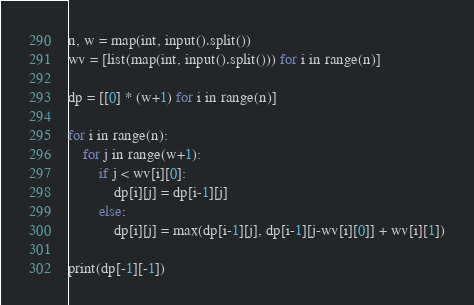Convert code to text. <code><loc_0><loc_0><loc_500><loc_500><_Python_>n, w = map(int, input().split())
wv = [list(map(int, input().split())) for i in range(n)]

dp = [[0] * (w+1) for i in range(n)]

for i in range(n):
    for j in range(w+1):
        if j < wv[i][0]:
            dp[i][j] = dp[i-1][j]
        else:
            dp[i][j] = max(dp[i-1][j], dp[i-1][j-wv[i][0]] + wv[i][1])

print(dp[-1][-1])</code> 